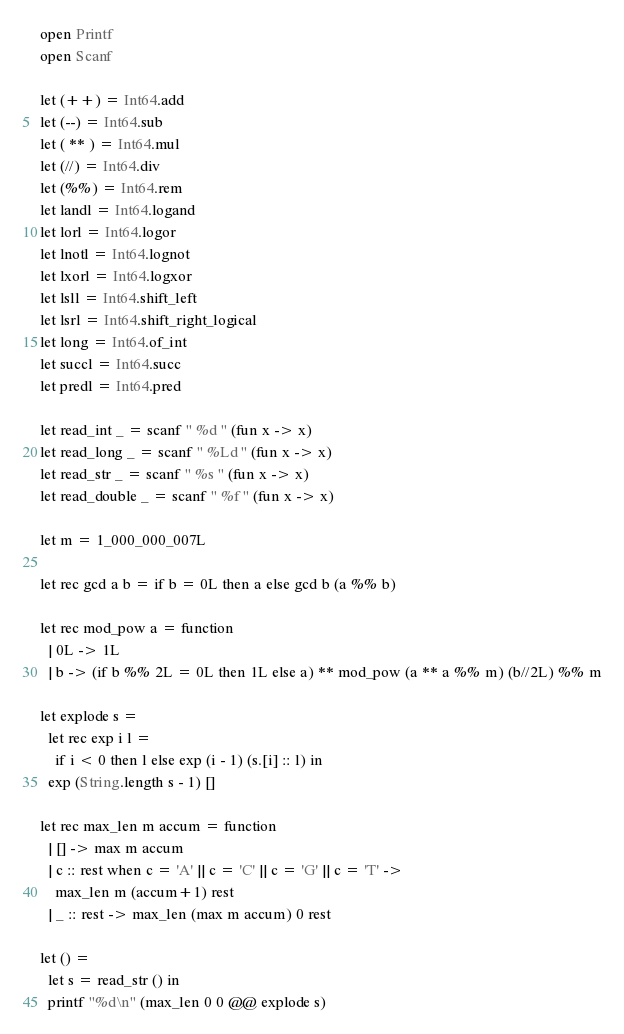<code> <loc_0><loc_0><loc_500><loc_500><_OCaml_>open Printf
open Scanf

let (++) = Int64.add
let (--) = Int64.sub
let ( ** ) = Int64.mul
let (//) = Int64.div
let (%%) = Int64.rem
let landl = Int64.logand
let lorl = Int64.logor
let lnotl = Int64.lognot
let lxorl = Int64.logxor
let lsll = Int64.shift_left
let lsrl = Int64.shift_right_logical
let long = Int64.of_int
let succl = Int64.succ
let predl = Int64.pred

let read_int _ = scanf " %d " (fun x -> x)
let read_long _ = scanf " %Ld " (fun x -> x)
let read_str _ = scanf " %s " (fun x -> x)
let read_double _ = scanf " %f " (fun x -> x)

let m = 1_000_000_007L

let rec gcd a b = if b = 0L then a else gcd b (a %% b)

let rec mod_pow a = function
  | 0L -> 1L
  | b -> (if b %% 2L = 0L then 1L else a) ** mod_pow (a ** a %% m) (b//2L) %% m

let explode s =
  let rec exp i l =
    if i < 0 then l else exp (i - 1) (s.[i] :: l) in
  exp (String.length s - 1) []

let rec max_len m accum = function
  | [] -> max m accum
  | c :: rest when c = 'A' || c = 'C' || c = 'G' || c = 'T' ->
    max_len m (accum+1) rest
  | _ :: rest -> max_len (max m accum) 0 rest

let () =
  let s = read_str () in
  printf "%d\n" (max_len 0 0 @@ explode s)
</code> 